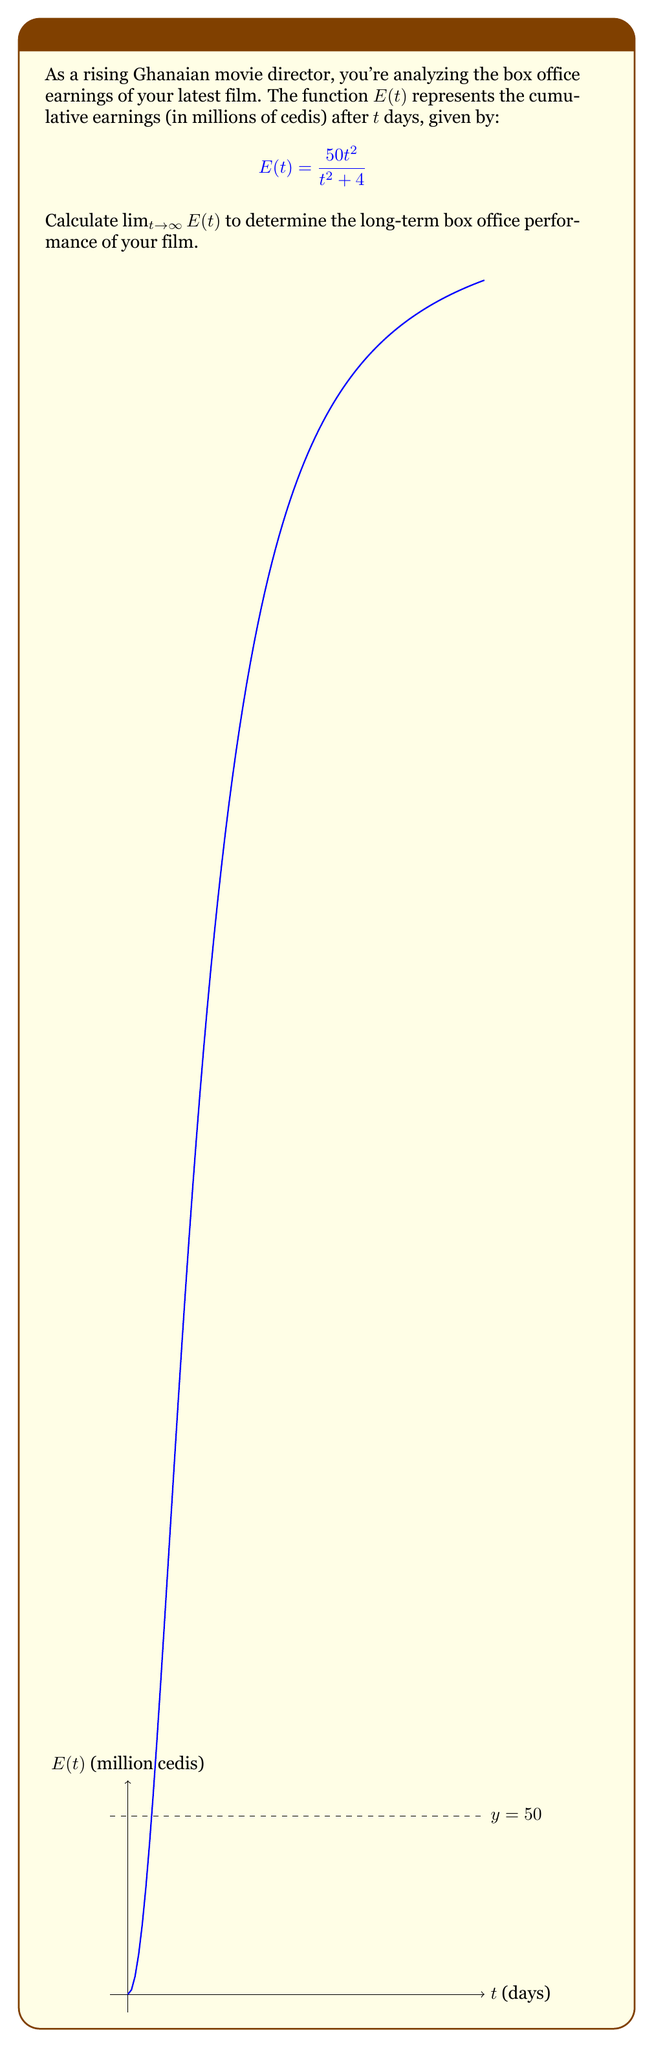Help me with this question. Let's approach this step-by-step:

1) We need to evaluate $\lim_{t \to \infty} \frac{50t^2}{t^2 + 4}$

2) Both the numerator and denominator approach infinity as $t$ approaches infinity. This is an indeterminate form of type $\frac{\infty}{\infty}$.

3) In such cases, we can divide both the numerator and denominator by the highest power of $t$ in the denominator. Here, it's $t^2$:

   $\lim_{t \to \infty} \frac{50t^2}{t^2 + 4} = \lim_{t \to \infty} \frac{50t^2/t^2}{(t^2 + 4)/t^2}$

4) Simplify:
   
   $\lim_{t \to \infty} \frac{50}{1 + 4/t^2}$

5) As $t$ approaches infinity, $4/t^2$ approaches 0:

   $\lim_{t \to \infty} \frac{50}{1 + 0} = 50$

Therefore, the long-term box office earnings of your film approach 50 million cedis.
Answer: 50 million cedis 